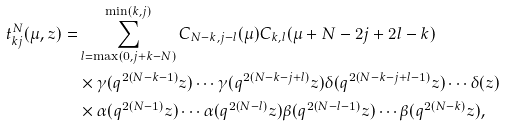Convert formula to latex. <formula><loc_0><loc_0><loc_500><loc_500>t ^ { N } _ { k j } ( \mu , z ) = & \sum _ { l = \max ( 0 , j + k - N ) } ^ { \min ( k , j ) } C _ { N - k , j - l } ( \mu ) C _ { k , l } ( \mu + N - 2 j + 2 l - k ) \\ & \times \gamma ( q ^ { 2 ( N - k - 1 ) } z ) \cdots \gamma ( q ^ { 2 ( N - k - j + l ) } z ) \delta ( q ^ { 2 ( N - k - j + l - 1 ) } z ) \cdots \delta ( z ) \\ & \times \alpha ( q ^ { 2 ( N - 1 ) } z ) \cdots \alpha ( q ^ { 2 ( N - l ) } z ) \beta ( q ^ { 2 ( N - l - 1 ) } z ) \cdots \beta ( q ^ { 2 ( N - k ) } z ) ,</formula> 